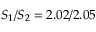Convert formula to latex. <formula><loc_0><loc_0><loc_500><loc_500>S _ { 1 } / S _ { 2 } = 2 . 0 2 / 2 . 0 5</formula> 